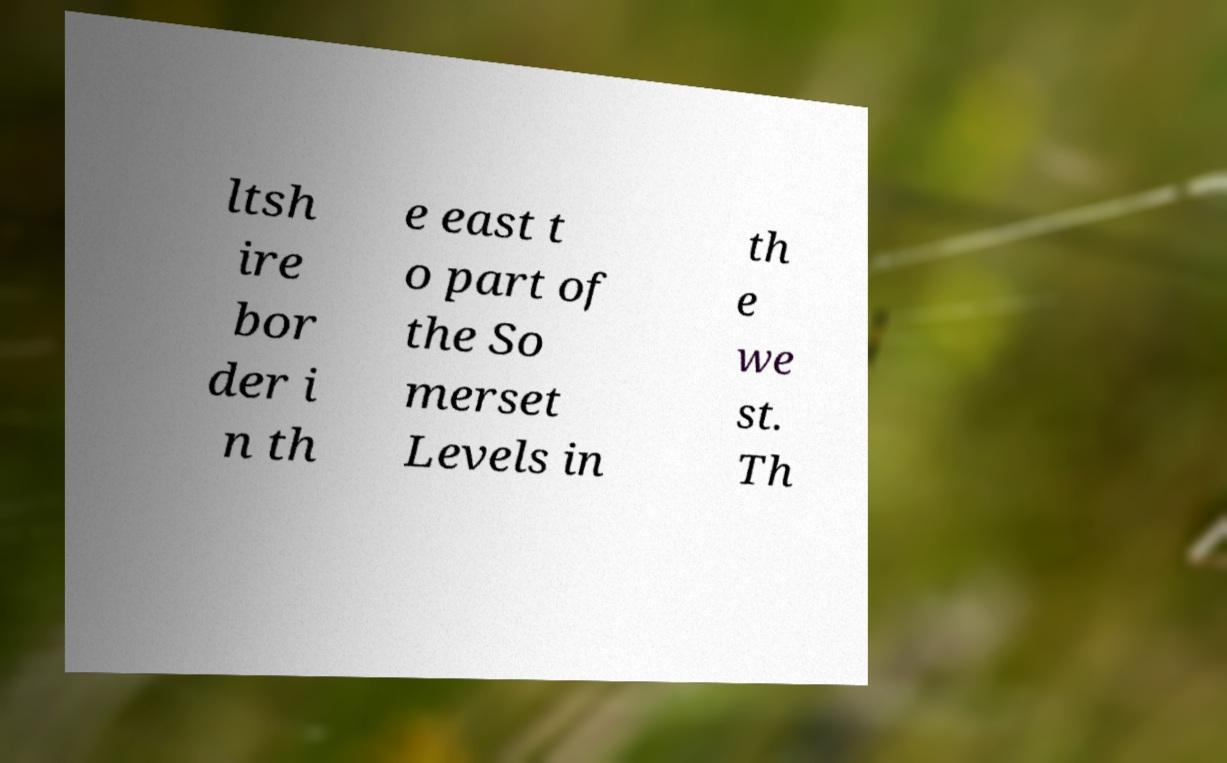Could you assist in decoding the text presented in this image and type it out clearly? ltsh ire bor der i n th e east t o part of the So merset Levels in th e we st. Th 